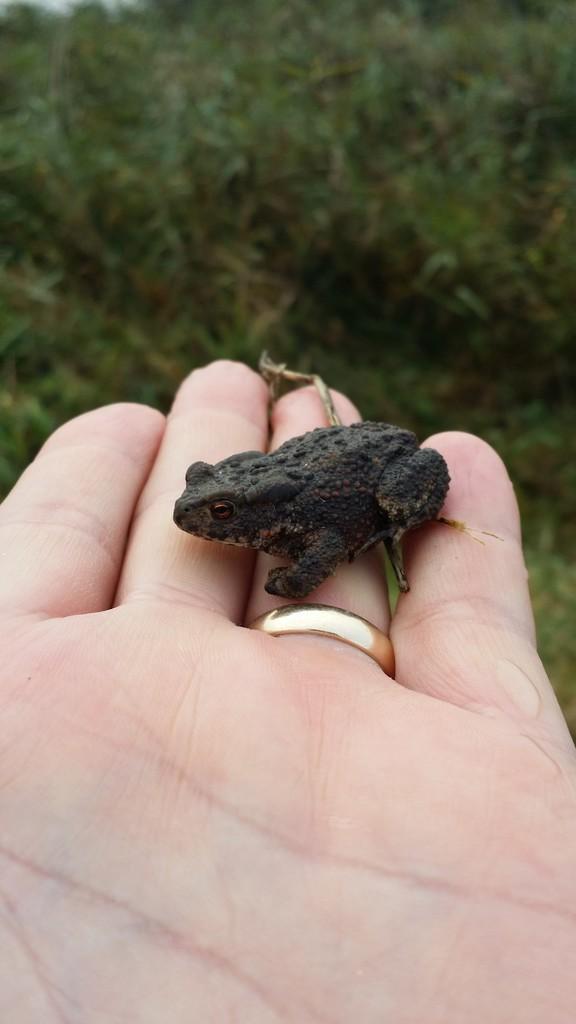Could you give a brief overview of what you see in this image? In this image there is a small black colour frog on the hand. In the background there are plants. 